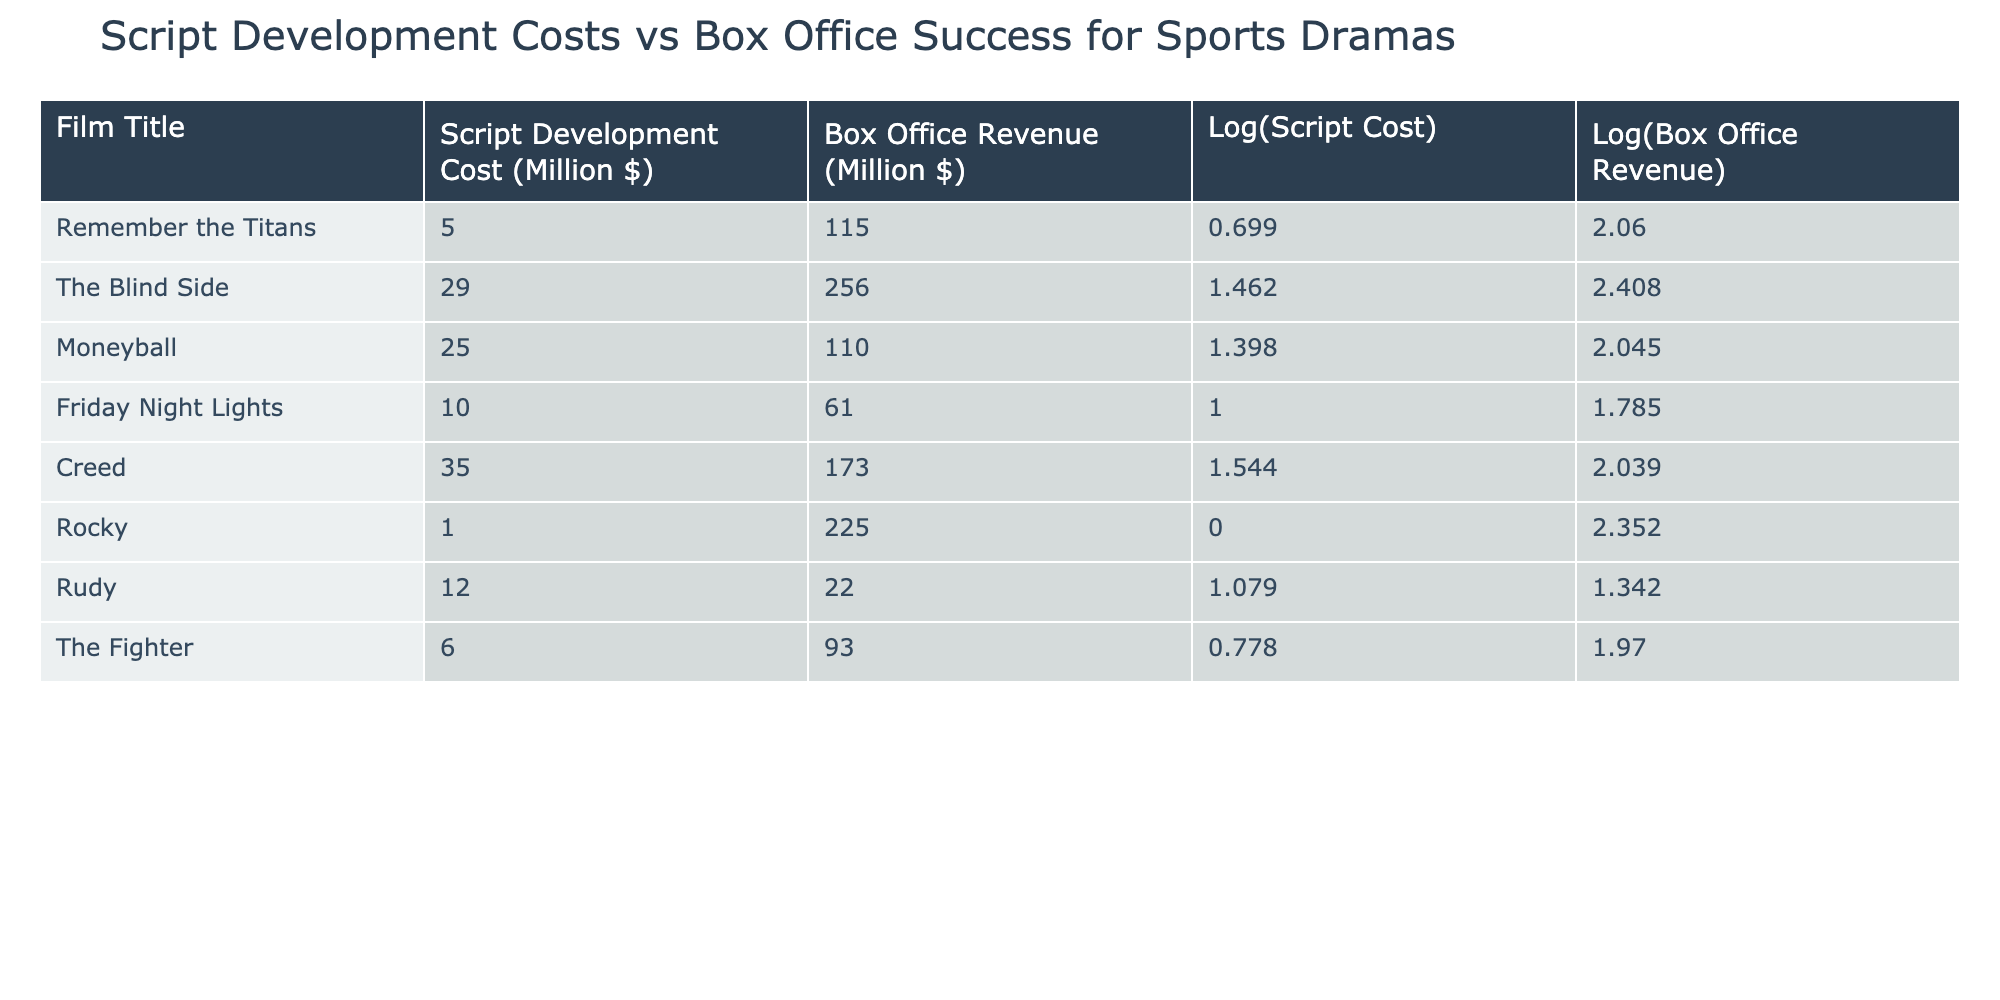What is the script development cost of "Creed"? The script development cost for "Creed" is provided in the table under that film's title. It directly shows the value for "Creed".
Answer: 35.00 million dollars Which film had the highest box office revenue? To find the highest box office revenue, examine the "Box Office Revenue" column and identify the maximum value. "Rocky" has the highest revenue at 225 million dollars.
Answer: Rocky had the highest box office revenue What is the average script development cost of the films listed? To calculate the average, sum up all the script development costs: (5 + 29 + 25 + 10 + 35 + 1 + 12 + 6) = 123. Then divide by the number of films, which is 8: 123/8 = 15.375.
Answer: 15.375 million dollars Is the box office revenue of "Moneyball" greater than 100 million dollars? Checking the box office revenue for "Moneyball", it is 110 million dollars, which is greater than 100 million dollars, thus confirming the statement.
Answer: Yes What is the difference in box office revenue between "The Blind Side" and "Friday Night Lights"? The box office revenue for "The Blind Side" is 256 million dollars, and for "Friday Night Lights" it is 61 million dollars. The difference is calculated as 256 - 61 = 195 million dollars.
Answer: 195 million dollars Which film had a lower script development cost: "Rudy" or "Rocky"? Comparing the script development costs for "Rudy" (12 million dollars) and "Rocky" (1 million dollars), "Rocky" has less cost, being lower than "Rudy".
Answer: Rocky What is the logarithm of the script development cost for "The Fighter"? Referring to "The Fighter", the logarithmic value of its script development cost is provided in the table as 0.778. This is a direct lookup from that row.
Answer: 0.778 How many films have a box office revenue greater than 200 million dollars? Evaluating the "Box Office Revenue" column, only "Rocky" has a revenue exceeding 200 million dollars. Count this value to determine how many films meet this criterion.
Answer: 1 film What is the median of the script development costs for these films? To find the median, first list the script development costs in order: 1, 5, 6, 10, 12, 25, 29, 35. As there are 8 values, the median is the average of the 4th and 5th values: (10 + 12)/2 = 11.
Answer: 11 million dollars 